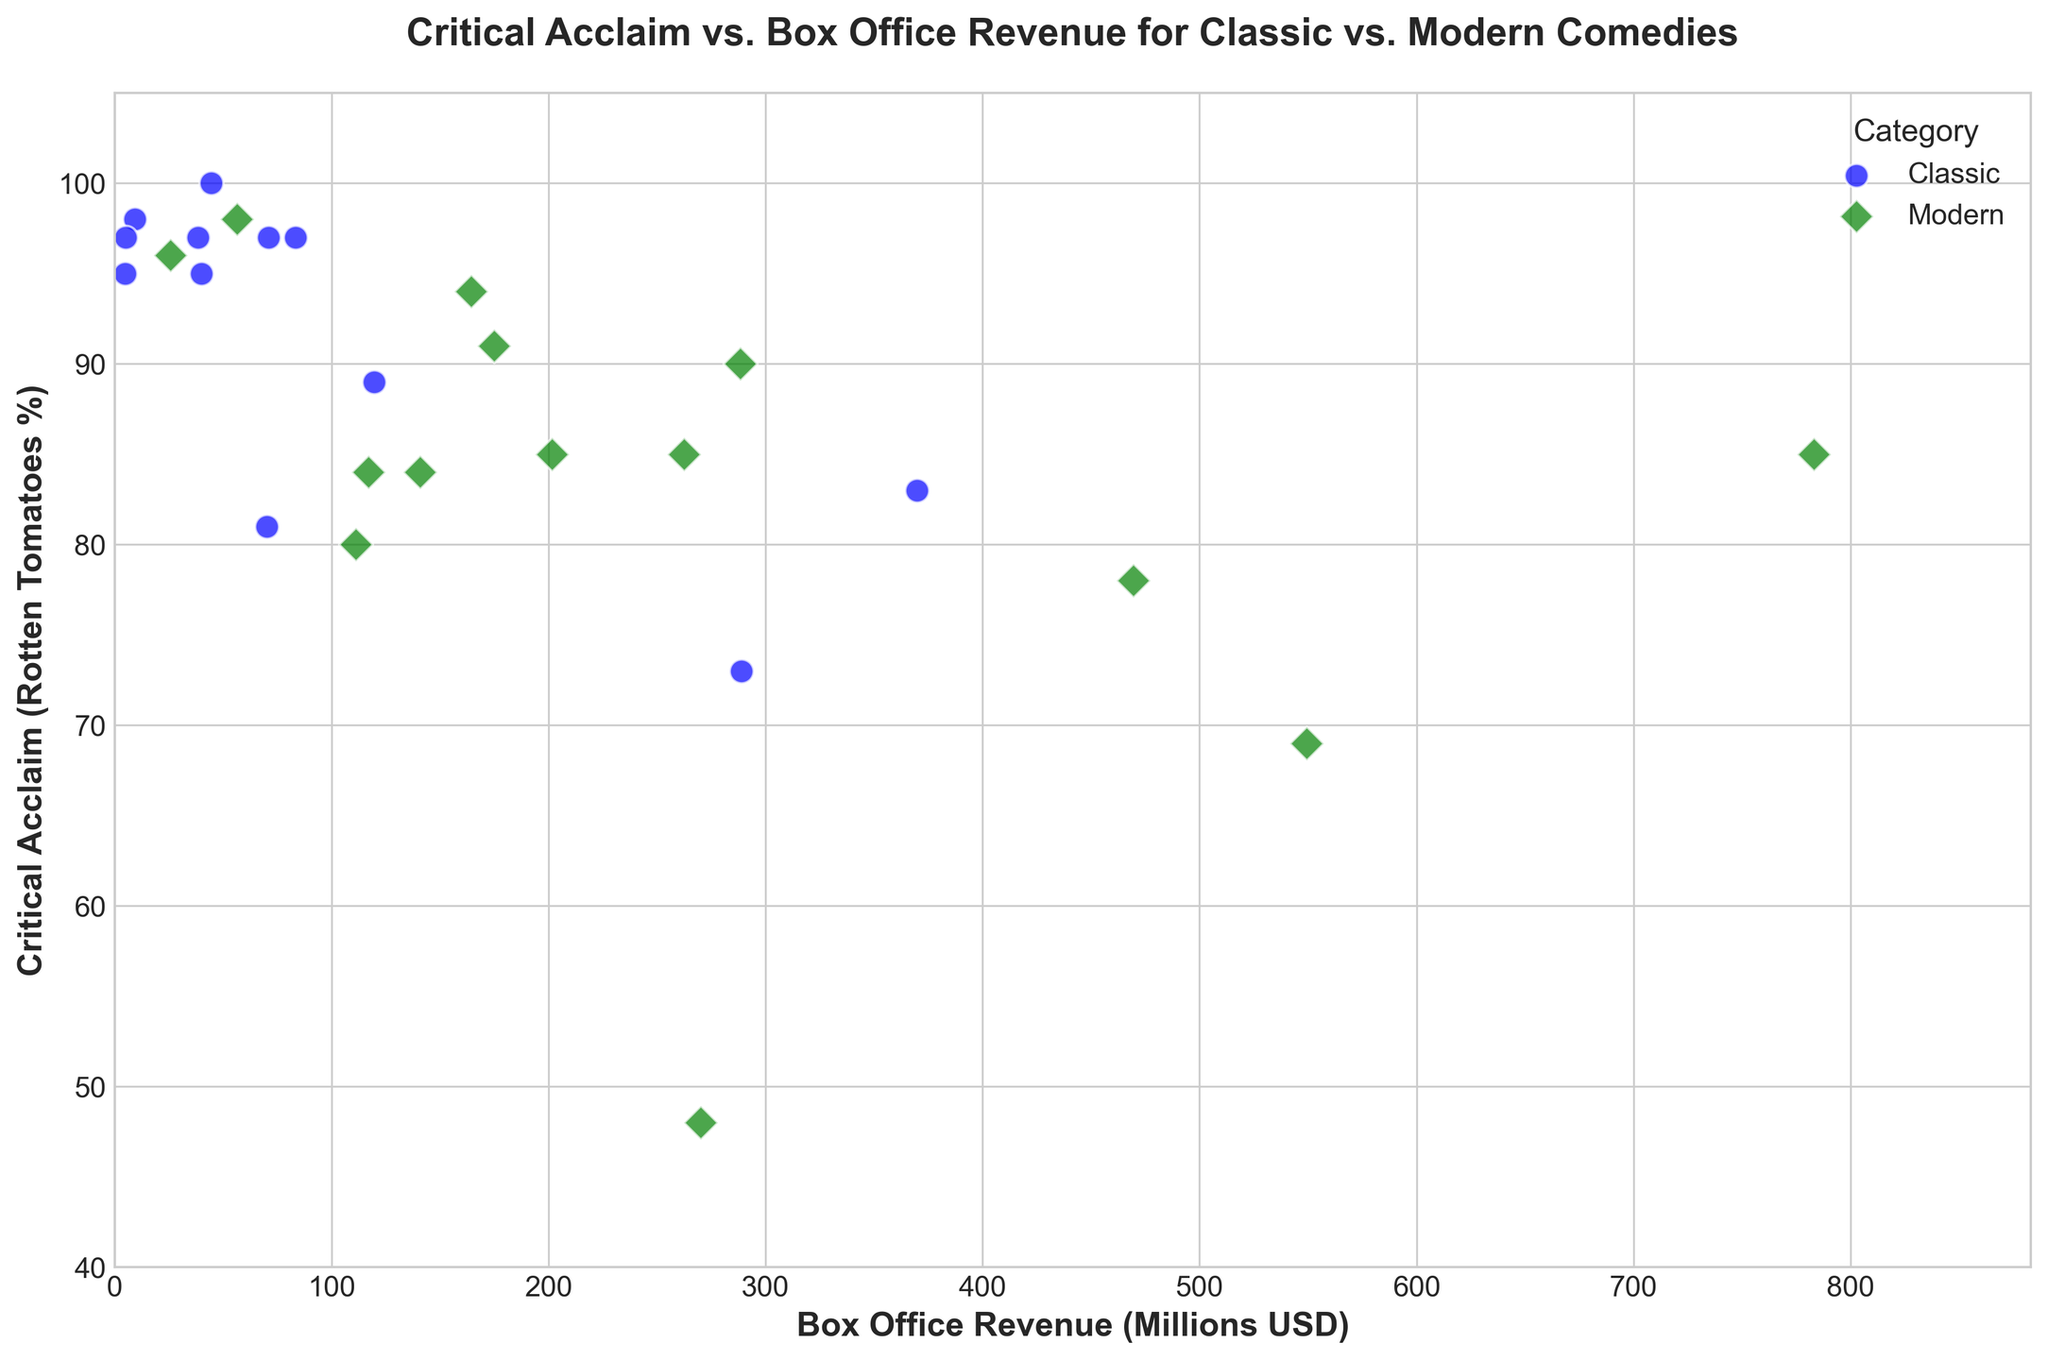Which movie has the highest critical acclaim in the Classic category? Look for the data points representing Classic comedies (marked in blue) and identify the one with the highest y-value (Critical Acclaim). "The Odd Couple" has the highest rating at 100%.
Answer: The Odd Couple Which movie has the highest box office revenue in the Modern category? Look for the green markers (Modern comedies) on the x-axis and identify the one with the highest x-value (Box Office Revenue). "Deadpool" has the highest revenue at 783.1 million USD.
Answer: Deadpool How many Modern comedies have critical acclaim equal to or higher than 90%? Count the number of green markers where the y-value (Critical Acclaim) is equal to or above 90. "Bridesmaids," "The Grand Budapest Hotel," "The Big Sick," "Booksmart," and "Palm Springs" meet this criterion.
Answer: 5 Which category has more movies with a box office revenue greater than 200 million USD? Count the number of blue markers (Classic) and green markers (Modern) where the x-value is greater than 200 million USD. Classics have 2 (There's Something About Mary and Coming to America), and Moderns have 6 (The Hangover, Bridesmaids, 21 Jump Street, Ted, We're the Millers, and Deadpool).
Answer: Modern What is the average critical acclaim for movies in the Classic category? Sum the y-values (Critical Acclaim) for all blue markers and divide by the number of Classic movies. (95+98+100+89+97+97+95+81+73+97+83) = 1005, divide by 11.
Answer: 91.36 Do Modern comedies generally have higher box office revenue than Classic comedies? Compare the distribution of green markers' x-values with blue markers' x-values. Green markers (Modern) tend to have higher x-values (Box Office Revenue), indicating modern comedies usually have higher revenues.
Answer: Yes How many Classic comedies have both a critical acclaim lower than 85% and a box office revenue above 50 million USD? Identify the blue markers where the y-value is less than 85% and the x-value is above 50 million USD. Ferris Bueller's Day Off (81%, 70.1 million USD) fits this criterion.
Answer: 1 Which Modern comedy made the highest box office revenue with a critical acclaim above 90%? Identify the green markers with a y-value above 90% and find the one with the highest x-value. "The Grand Budapest Hotel" has the highest revenue at 174.8 million USD among those with above 90% critical acclaim.
Answer: The Grand Budapest Hotel Between the movie with the lowest box office revenue and the movie with the highest critical acclaim in the Classic category, what is the difference in their critical acclaim values? The movie with the lowest revenue in the Classic category is "Monty Python and the Holy Grail" (5 million USD, 97%), and the one with the highest critical acclaim is "The Odd Couple" (44.5 million USD, 100%). The difference in their critical acclaim is 100% - 97% = 3%.
Answer: 3% Which Modern comedy has the closest box office revenue to 100 million USD? Look for the green markers where the x-values are closest to 100 million USD. "Good Boys" has a box office revenue of 111.2 million USD, which is the closest to 100 million USD.
Answer: Good Boys 